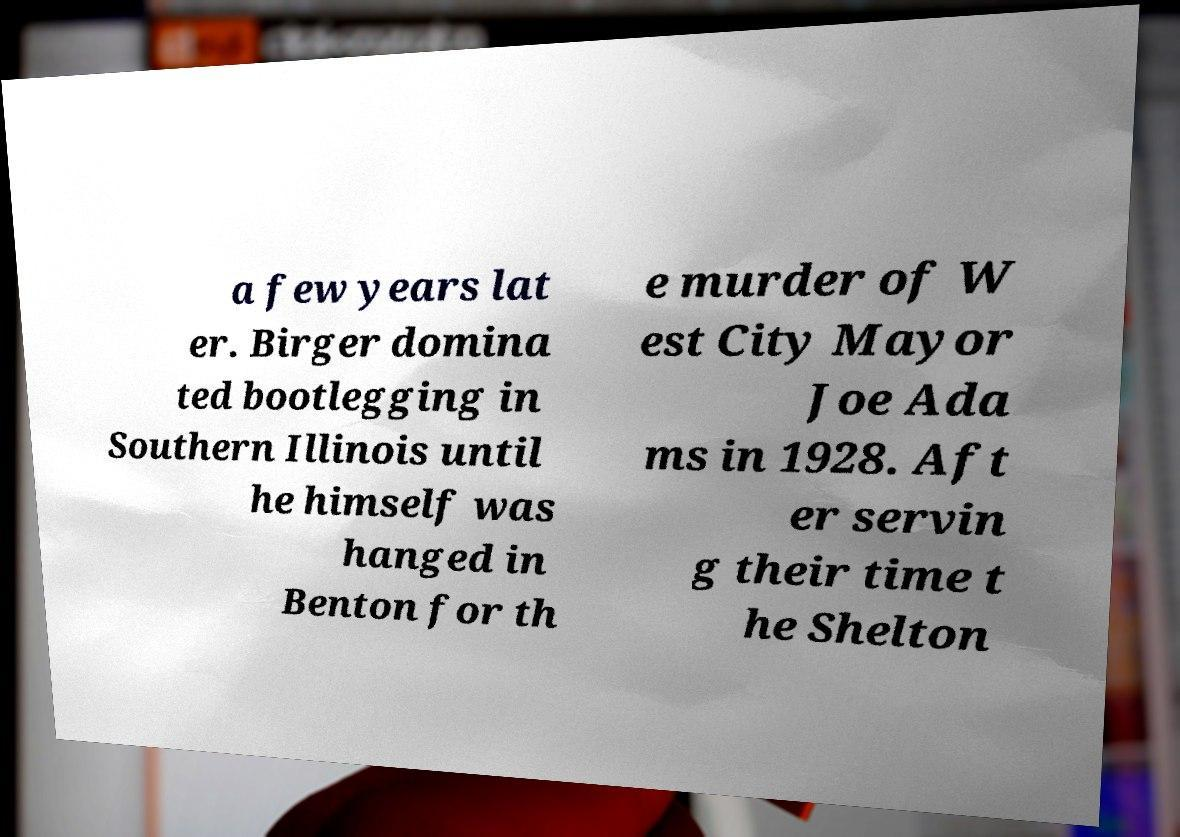What messages or text are displayed in this image? I need them in a readable, typed format. a few years lat er. Birger domina ted bootlegging in Southern Illinois until he himself was hanged in Benton for th e murder of W est City Mayor Joe Ada ms in 1928. Aft er servin g their time t he Shelton 